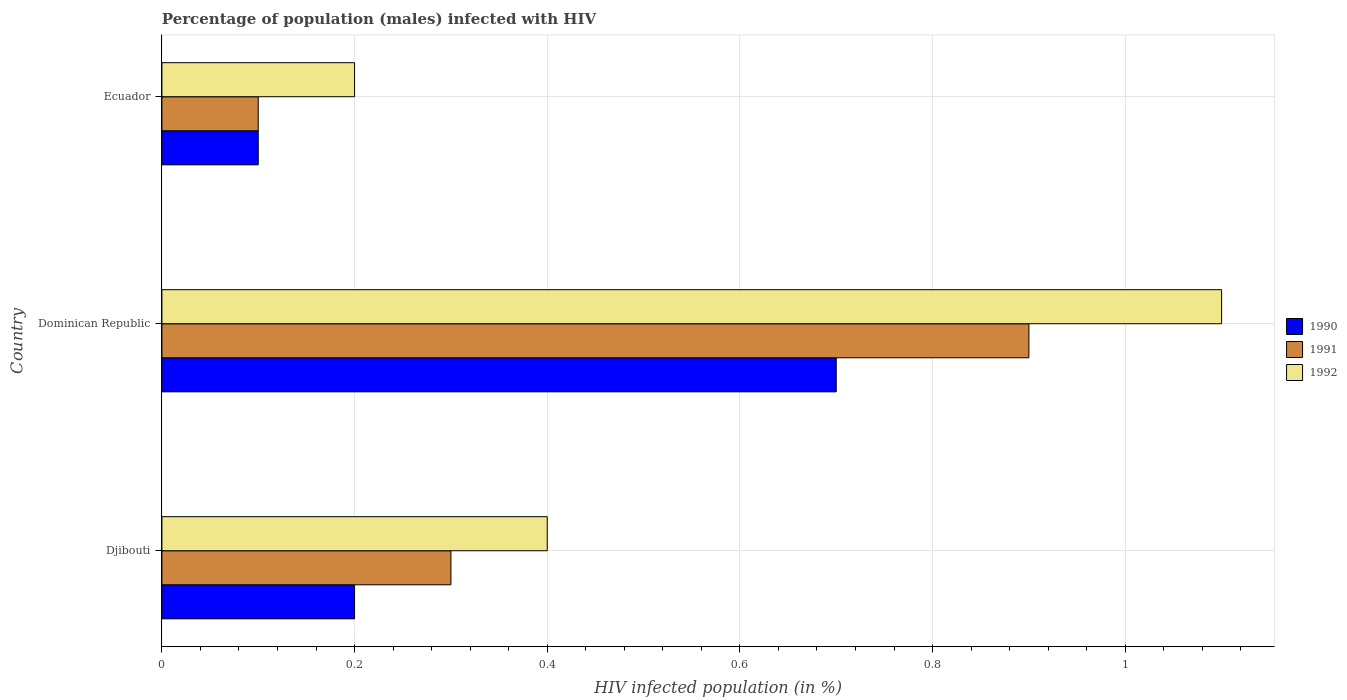How many groups of bars are there?
Offer a terse response. 3. Are the number of bars per tick equal to the number of legend labels?
Make the answer very short. Yes. Are the number of bars on each tick of the Y-axis equal?
Give a very brief answer. Yes. How many bars are there on the 2nd tick from the bottom?
Provide a short and direct response. 3. What is the label of the 3rd group of bars from the top?
Keep it short and to the point. Djibouti. In which country was the percentage of HIV infected male population in 1990 maximum?
Ensure brevity in your answer.  Dominican Republic. In which country was the percentage of HIV infected male population in 1991 minimum?
Keep it short and to the point. Ecuador. What is the total percentage of HIV infected male population in 1992 in the graph?
Offer a terse response. 1.7. What is the difference between the percentage of HIV infected male population in 1990 in Djibouti and that in Dominican Republic?
Your answer should be compact. -0.5. What is the difference between the percentage of HIV infected male population in 1991 in Djibouti and the percentage of HIV infected male population in 1990 in Ecuador?
Provide a succinct answer. 0.2. What is the average percentage of HIV infected male population in 1990 per country?
Provide a short and direct response. 0.33. What is the difference between the percentage of HIV infected male population in 1990 and percentage of HIV infected male population in 1992 in Dominican Republic?
Provide a succinct answer. -0.4. In how many countries, is the percentage of HIV infected male population in 1992 greater than 0.2 %?
Give a very brief answer. 2. What is the ratio of the percentage of HIV infected male population in 1992 in Djibouti to that in Dominican Republic?
Offer a very short reply. 0.36. Is the difference between the percentage of HIV infected male population in 1990 in Djibouti and Dominican Republic greater than the difference between the percentage of HIV infected male population in 1992 in Djibouti and Dominican Republic?
Your response must be concise. Yes. What is the difference between the highest and the second highest percentage of HIV infected male population in 1992?
Offer a terse response. 0.7. What is the difference between the highest and the lowest percentage of HIV infected male population in 1992?
Your answer should be compact. 0.9. In how many countries, is the percentage of HIV infected male population in 1992 greater than the average percentage of HIV infected male population in 1992 taken over all countries?
Provide a succinct answer. 1. Is the sum of the percentage of HIV infected male population in 1992 in Dominican Republic and Ecuador greater than the maximum percentage of HIV infected male population in 1991 across all countries?
Provide a succinct answer. Yes. Is it the case that in every country, the sum of the percentage of HIV infected male population in 1990 and percentage of HIV infected male population in 1992 is greater than the percentage of HIV infected male population in 1991?
Provide a succinct answer. Yes. How many bars are there?
Provide a succinct answer. 9. Are all the bars in the graph horizontal?
Your answer should be very brief. Yes. What is the difference between two consecutive major ticks on the X-axis?
Give a very brief answer. 0.2. Does the graph contain grids?
Offer a terse response. Yes. Where does the legend appear in the graph?
Give a very brief answer. Center right. How many legend labels are there?
Your answer should be compact. 3. What is the title of the graph?
Make the answer very short. Percentage of population (males) infected with HIV. What is the label or title of the X-axis?
Offer a very short reply. HIV infected population (in %). What is the HIV infected population (in %) of 1990 in Djibouti?
Your response must be concise. 0.2. What is the HIV infected population (in %) of 1991 in Djibouti?
Keep it short and to the point. 0.3. What is the HIV infected population (in %) in 1992 in Djibouti?
Give a very brief answer. 0.4. What is the HIV infected population (in %) in 1991 in Dominican Republic?
Provide a succinct answer. 0.9. What is the HIV infected population (in %) in 1992 in Ecuador?
Your response must be concise. 0.2. Across all countries, what is the minimum HIV infected population (in %) of 1990?
Your answer should be very brief. 0.1. Across all countries, what is the minimum HIV infected population (in %) of 1991?
Your answer should be compact. 0.1. What is the total HIV infected population (in %) in 1990 in the graph?
Your answer should be very brief. 1. What is the total HIV infected population (in %) of 1992 in the graph?
Give a very brief answer. 1.7. What is the difference between the HIV infected population (in %) of 1992 in Dominican Republic and that in Ecuador?
Give a very brief answer. 0.9. What is the difference between the HIV infected population (in %) of 1990 in Djibouti and the HIV infected population (in %) of 1991 in Dominican Republic?
Provide a succinct answer. -0.7. What is the difference between the HIV infected population (in %) of 1990 in Djibouti and the HIV infected population (in %) of 1992 in Dominican Republic?
Provide a succinct answer. -0.9. What is the difference between the HIV infected population (in %) in 1991 in Djibouti and the HIV infected population (in %) in 1992 in Dominican Republic?
Offer a terse response. -0.8. What is the difference between the HIV infected population (in %) in 1990 in Djibouti and the HIV infected population (in %) in 1991 in Ecuador?
Make the answer very short. 0.1. What is the difference between the HIV infected population (in %) of 1990 in Djibouti and the HIV infected population (in %) of 1992 in Ecuador?
Give a very brief answer. 0. What is the difference between the HIV infected population (in %) in 1991 in Djibouti and the HIV infected population (in %) in 1992 in Ecuador?
Your answer should be compact. 0.1. What is the difference between the HIV infected population (in %) in 1990 in Dominican Republic and the HIV infected population (in %) in 1991 in Ecuador?
Your answer should be very brief. 0.6. What is the difference between the HIV infected population (in %) of 1991 in Dominican Republic and the HIV infected population (in %) of 1992 in Ecuador?
Offer a very short reply. 0.7. What is the average HIV infected population (in %) in 1991 per country?
Your answer should be compact. 0.43. What is the average HIV infected population (in %) of 1992 per country?
Keep it short and to the point. 0.57. What is the difference between the HIV infected population (in %) in 1990 and HIV infected population (in %) in 1991 in Djibouti?
Provide a short and direct response. -0.1. What is the difference between the HIV infected population (in %) in 1990 and HIV infected population (in %) in 1992 in Djibouti?
Your answer should be very brief. -0.2. What is the difference between the HIV infected population (in %) of 1990 and HIV infected population (in %) of 1991 in Dominican Republic?
Provide a short and direct response. -0.2. What is the difference between the HIV infected population (in %) in 1990 and HIV infected population (in %) in 1992 in Dominican Republic?
Offer a terse response. -0.4. What is the difference between the HIV infected population (in %) of 1990 and HIV infected population (in %) of 1991 in Ecuador?
Make the answer very short. 0. What is the ratio of the HIV infected population (in %) of 1990 in Djibouti to that in Dominican Republic?
Offer a very short reply. 0.29. What is the ratio of the HIV infected population (in %) in 1991 in Djibouti to that in Dominican Republic?
Offer a terse response. 0.33. What is the ratio of the HIV infected population (in %) in 1992 in Djibouti to that in Dominican Republic?
Your answer should be very brief. 0.36. What is the ratio of the HIV infected population (in %) of 1990 in Djibouti to that in Ecuador?
Keep it short and to the point. 2. What is the difference between the highest and the second highest HIV infected population (in %) of 1990?
Offer a very short reply. 0.5. What is the difference between the highest and the second highest HIV infected population (in %) in 1991?
Offer a very short reply. 0.6. What is the difference between the highest and the lowest HIV infected population (in %) of 1992?
Your response must be concise. 0.9. 